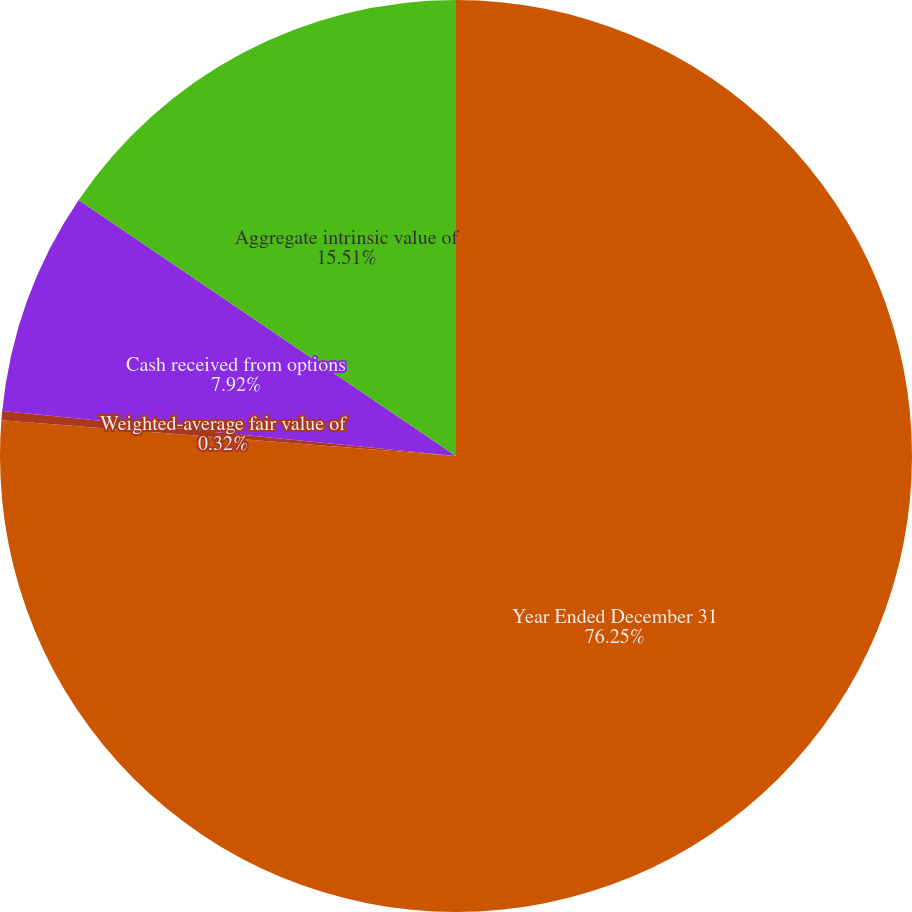<chart> <loc_0><loc_0><loc_500><loc_500><pie_chart><fcel>Year Ended December 31<fcel>Weighted-average fair value of<fcel>Cash received from options<fcel>Aggregate intrinsic value of<nl><fcel>76.25%<fcel>0.32%<fcel>7.92%<fcel>15.51%<nl></chart> 